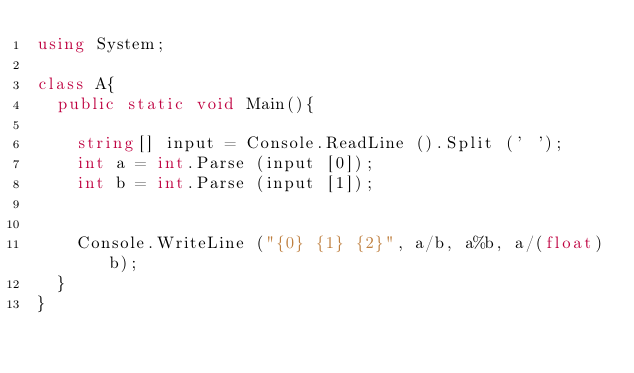Convert code to text. <code><loc_0><loc_0><loc_500><loc_500><_C#_>using System;

class A{
	public static void Main(){

		string[] input = Console.ReadLine ().Split (' ');
		int a = int.Parse (input [0]);
		int b = int.Parse (input [1]);


		Console.WriteLine ("{0} {1} {2}", a/b, a%b, a/(float)b);
	}
}</code> 